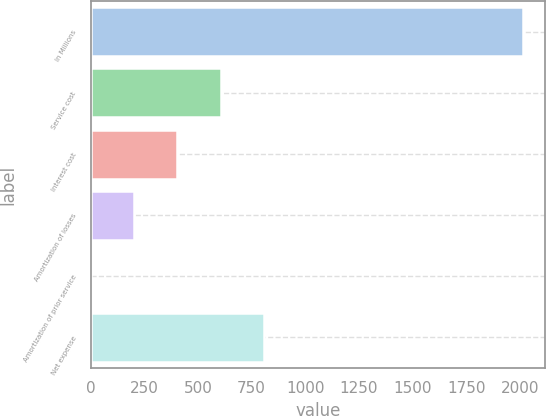<chart> <loc_0><loc_0><loc_500><loc_500><bar_chart><fcel>In Millions<fcel>Service cost<fcel>Interest cost<fcel>Amortization of losses<fcel>Amortization of prior service<fcel>Net expense<nl><fcel>2017<fcel>605.52<fcel>403.88<fcel>202.24<fcel>0.6<fcel>807.16<nl></chart> 